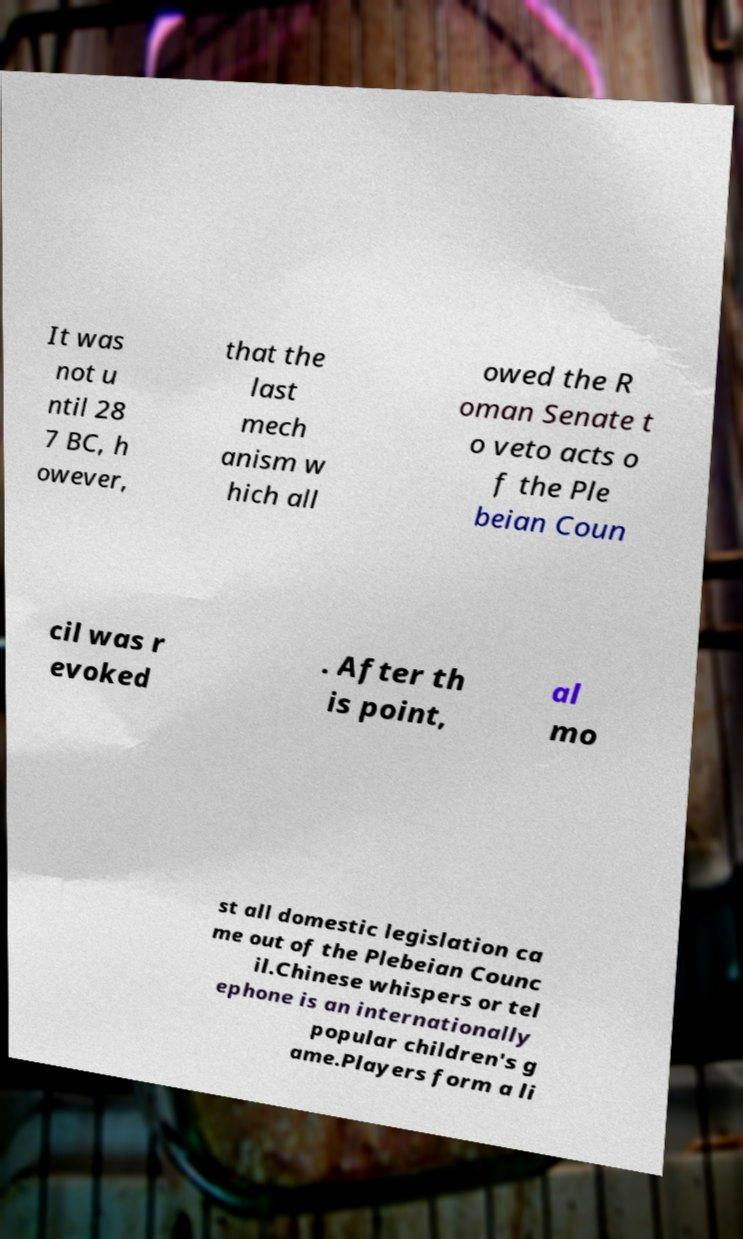Can you read and provide the text displayed in the image?This photo seems to have some interesting text. Can you extract and type it out for me? It was not u ntil 28 7 BC, h owever, that the last mech anism w hich all owed the R oman Senate t o veto acts o f the Ple beian Coun cil was r evoked . After th is point, al mo st all domestic legislation ca me out of the Plebeian Counc il.Chinese whispers or tel ephone is an internationally popular children's g ame.Players form a li 